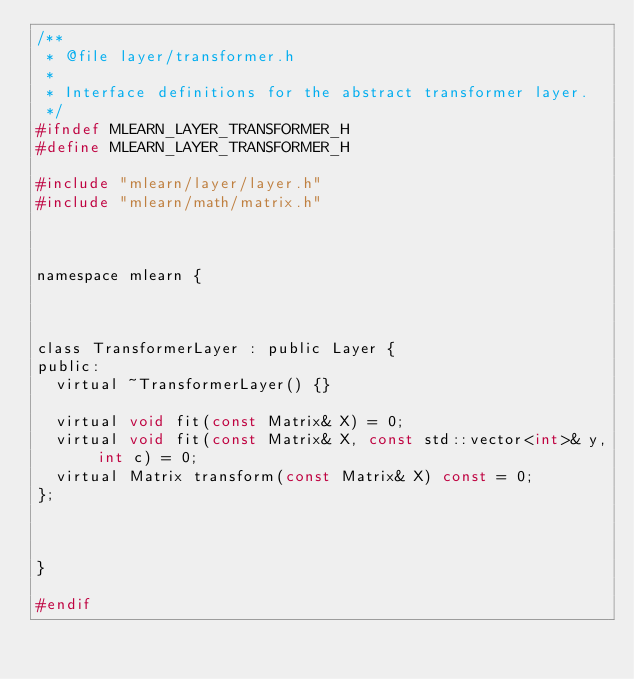<code> <loc_0><loc_0><loc_500><loc_500><_C_>/**
 * @file layer/transformer.h
 *
 * Interface definitions for the abstract transformer layer.
 */
#ifndef MLEARN_LAYER_TRANSFORMER_H
#define MLEARN_LAYER_TRANSFORMER_H

#include "mlearn/layer/layer.h"
#include "mlearn/math/matrix.h"



namespace mlearn {



class TransformerLayer : public Layer {
public:
	virtual ~TransformerLayer() {}

	virtual void fit(const Matrix& X) = 0;
	virtual void fit(const Matrix& X, const std::vector<int>& y, int c) = 0;
	virtual Matrix transform(const Matrix& X) const = 0;
};



}

#endif
</code> 